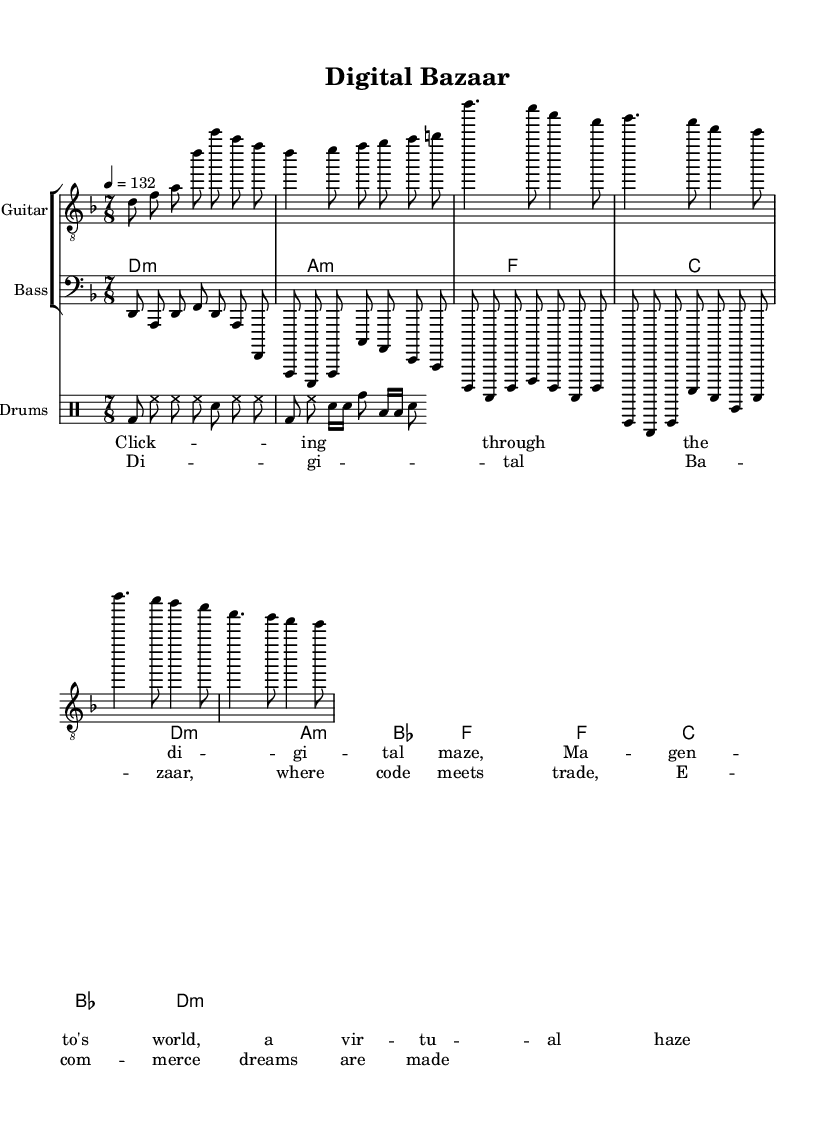What is the key signature of this music? The music is in D minor, which has one flat (B flat) in its key signature. This can be determined by looking at the key indication at the beginning of the music, denoted by the 'D' followed by 'minor'.
Answer: D minor What is the time signature of this music? The time signature is 7/8, as indicated at the beginning of the score. This tells us that there are seven beats in each measure, and the eighth note receives one beat.
Answer: 7/8 What is the tempo marking for this piece? The tempo marking indicates a speed of 132 beats per minute, as noted beside the tempo indication '4 = 132'. This means that quarter notes are played at a speed of 132 beats.
Answer: 132 How many measures are there in the verse section? The verse consists of four measures, which can be counted from the corresponding staff where the verse music starts. Each of the contiguously written sections represents a measure.
Answer: 4 Which instrument plays the intro? The intro is played by the Electric Guitar, as identified in the staff labeled 'Electric Guitar' at the top of the respective section.
Answer: Electric Guitar What is the lyric theme of the chorus? The lyrics of the chorus focus on e-commerce concepts, as reflected in the words "Digital Bazaar, where code meets trade, E-commerce dreams are made." This shows the theme surrounding digital marketplaces.
Answer: E-commerce What type of drum patterns are used in this piece? The drum patterns include basic patterns and fills that combine bass drum, hi-hat, snare, and toms, illustrating standard rock drumming techniques with variations for dynamic contrast.
Answer: Rock drumming 